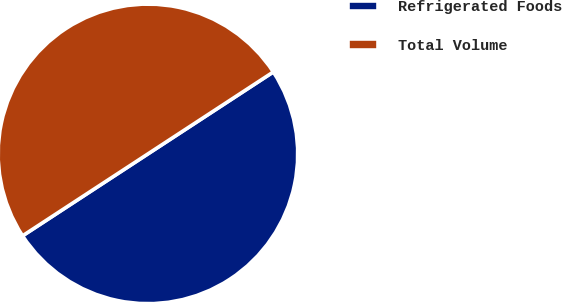Convert chart. <chart><loc_0><loc_0><loc_500><loc_500><pie_chart><fcel>Refrigerated Foods<fcel>Total Volume<nl><fcel>50.0%<fcel>50.0%<nl></chart> 